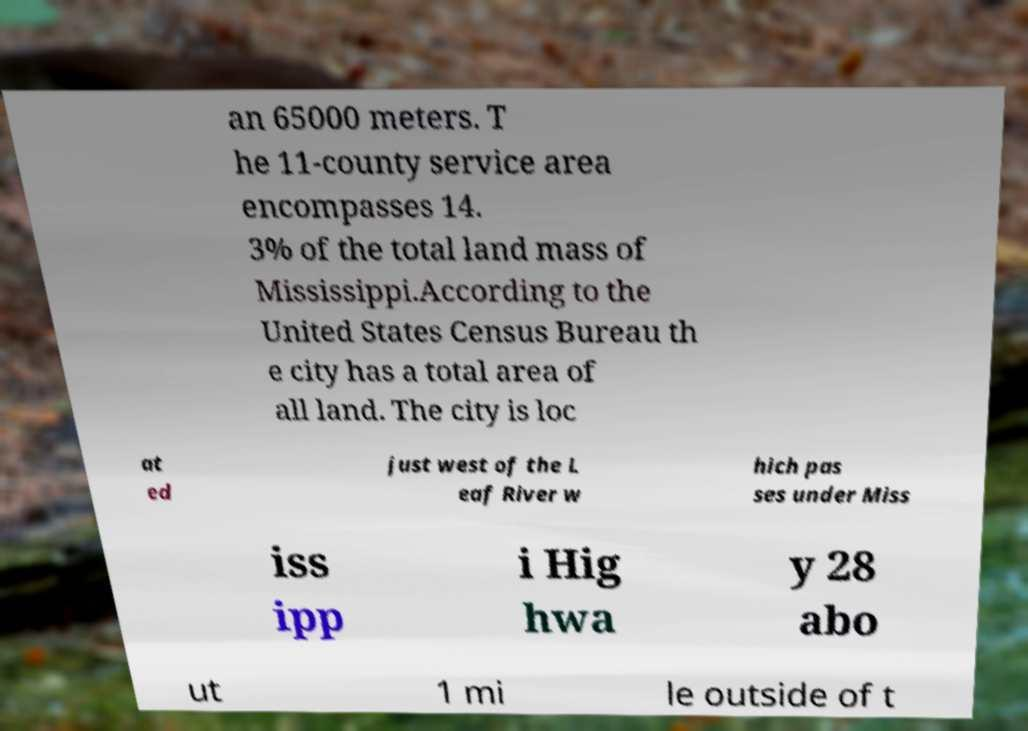Can you accurately transcribe the text from the provided image for me? an 65000 meters. T he 11-county service area encompasses 14. 3% of the total land mass of Mississippi.According to the United States Census Bureau th e city has a total area of all land. The city is loc at ed just west of the L eaf River w hich pas ses under Miss iss ipp i Hig hwa y 28 abo ut 1 mi le outside of t 